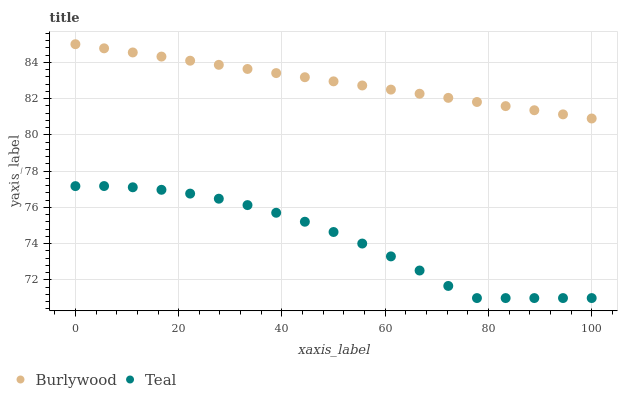Does Teal have the minimum area under the curve?
Answer yes or no. Yes. Does Burlywood have the maximum area under the curve?
Answer yes or no. Yes. Does Teal have the maximum area under the curve?
Answer yes or no. No. Is Burlywood the smoothest?
Answer yes or no. Yes. Is Teal the roughest?
Answer yes or no. Yes. Is Teal the smoothest?
Answer yes or no. No. Does Teal have the lowest value?
Answer yes or no. Yes. Does Burlywood have the highest value?
Answer yes or no. Yes. Does Teal have the highest value?
Answer yes or no. No. Is Teal less than Burlywood?
Answer yes or no. Yes. Is Burlywood greater than Teal?
Answer yes or no. Yes. Does Teal intersect Burlywood?
Answer yes or no. No. 